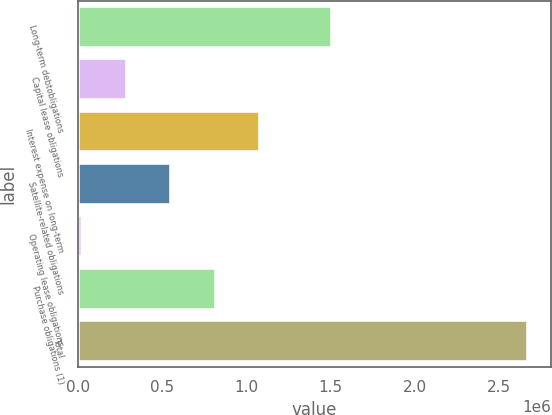Convert chart. <chart><loc_0><loc_0><loc_500><loc_500><bar_chart><fcel>Long-term debtobligations<fcel>Capital lease obligations<fcel>Interest expense on long-term<fcel>Satellite-related obligations<fcel>Operating lease obligations<fcel>Purchase obligations (1)<fcel>Total<nl><fcel>1.50674e+06<fcel>288270<fcel>1.08445e+06<fcel>553662<fcel>22878<fcel>819054<fcel>2.6768e+06<nl></chart> 